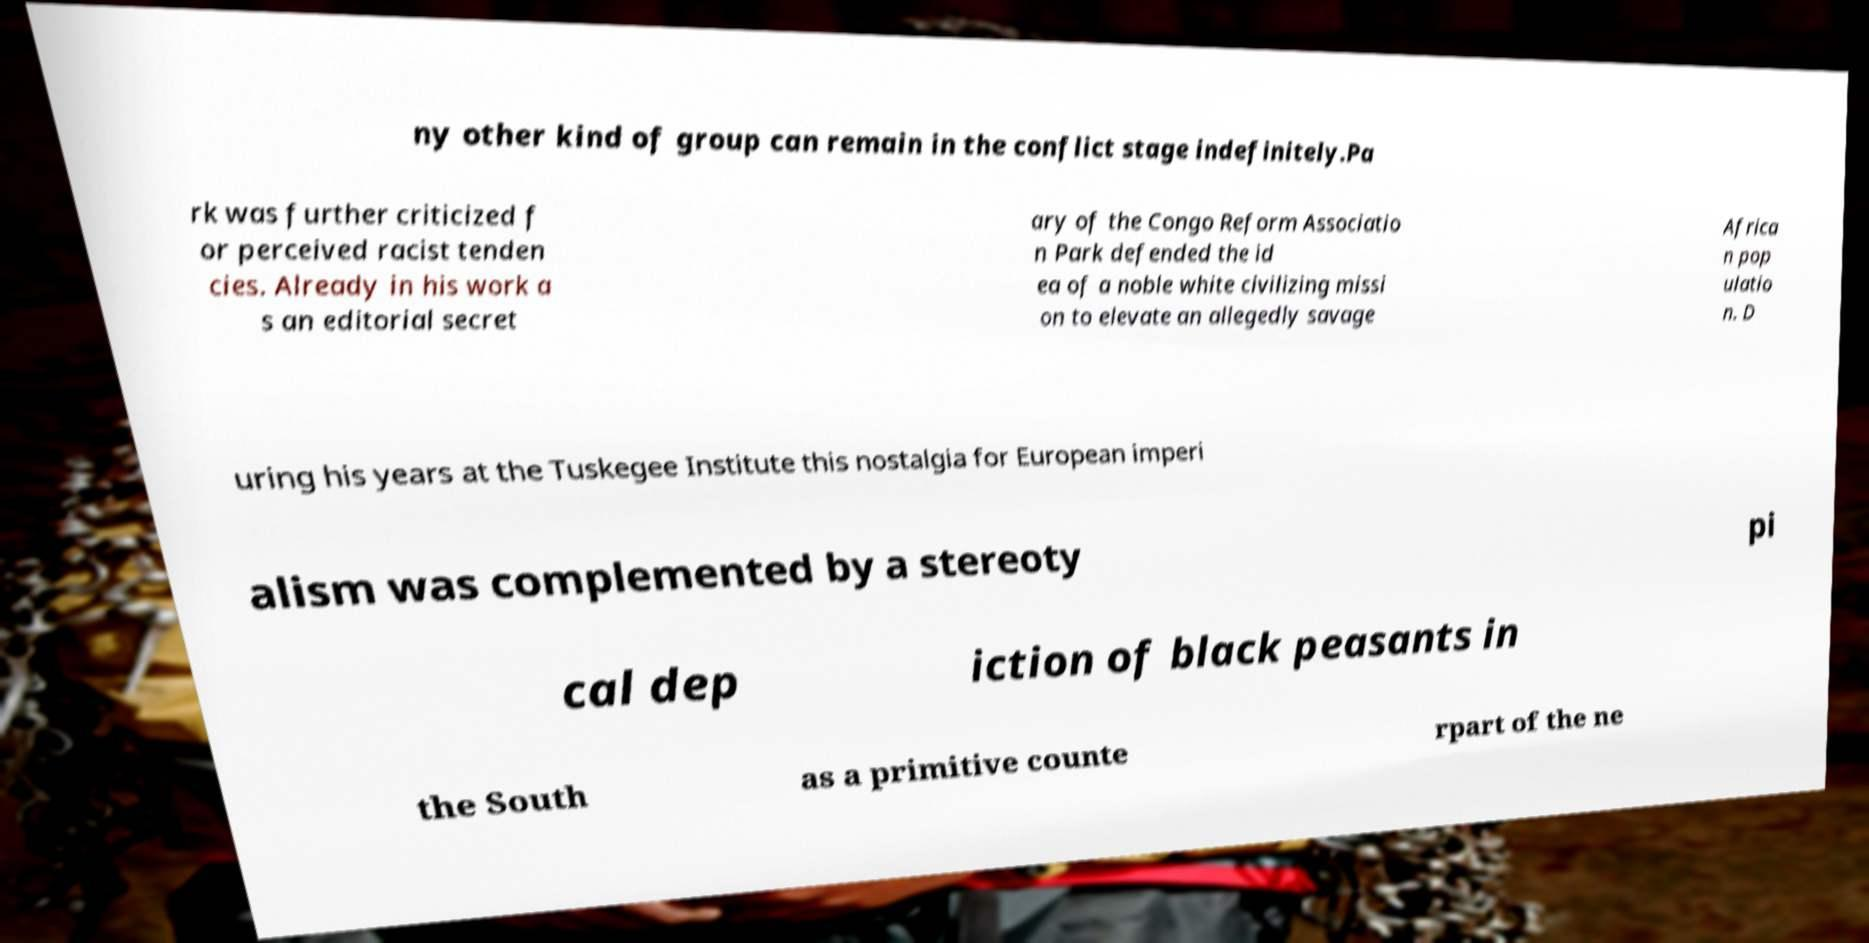Please identify and transcribe the text found in this image. ny other kind of group can remain in the conflict stage indefinitely.Pa rk was further criticized f or perceived racist tenden cies. Already in his work a s an editorial secret ary of the Congo Reform Associatio n Park defended the id ea of a noble white civilizing missi on to elevate an allegedly savage Africa n pop ulatio n. D uring his years at the Tuskegee Institute this nostalgia for European imperi alism was complemented by a stereoty pi cal dep iction of black peasants in the South as a primitive counte rpart of the ne 